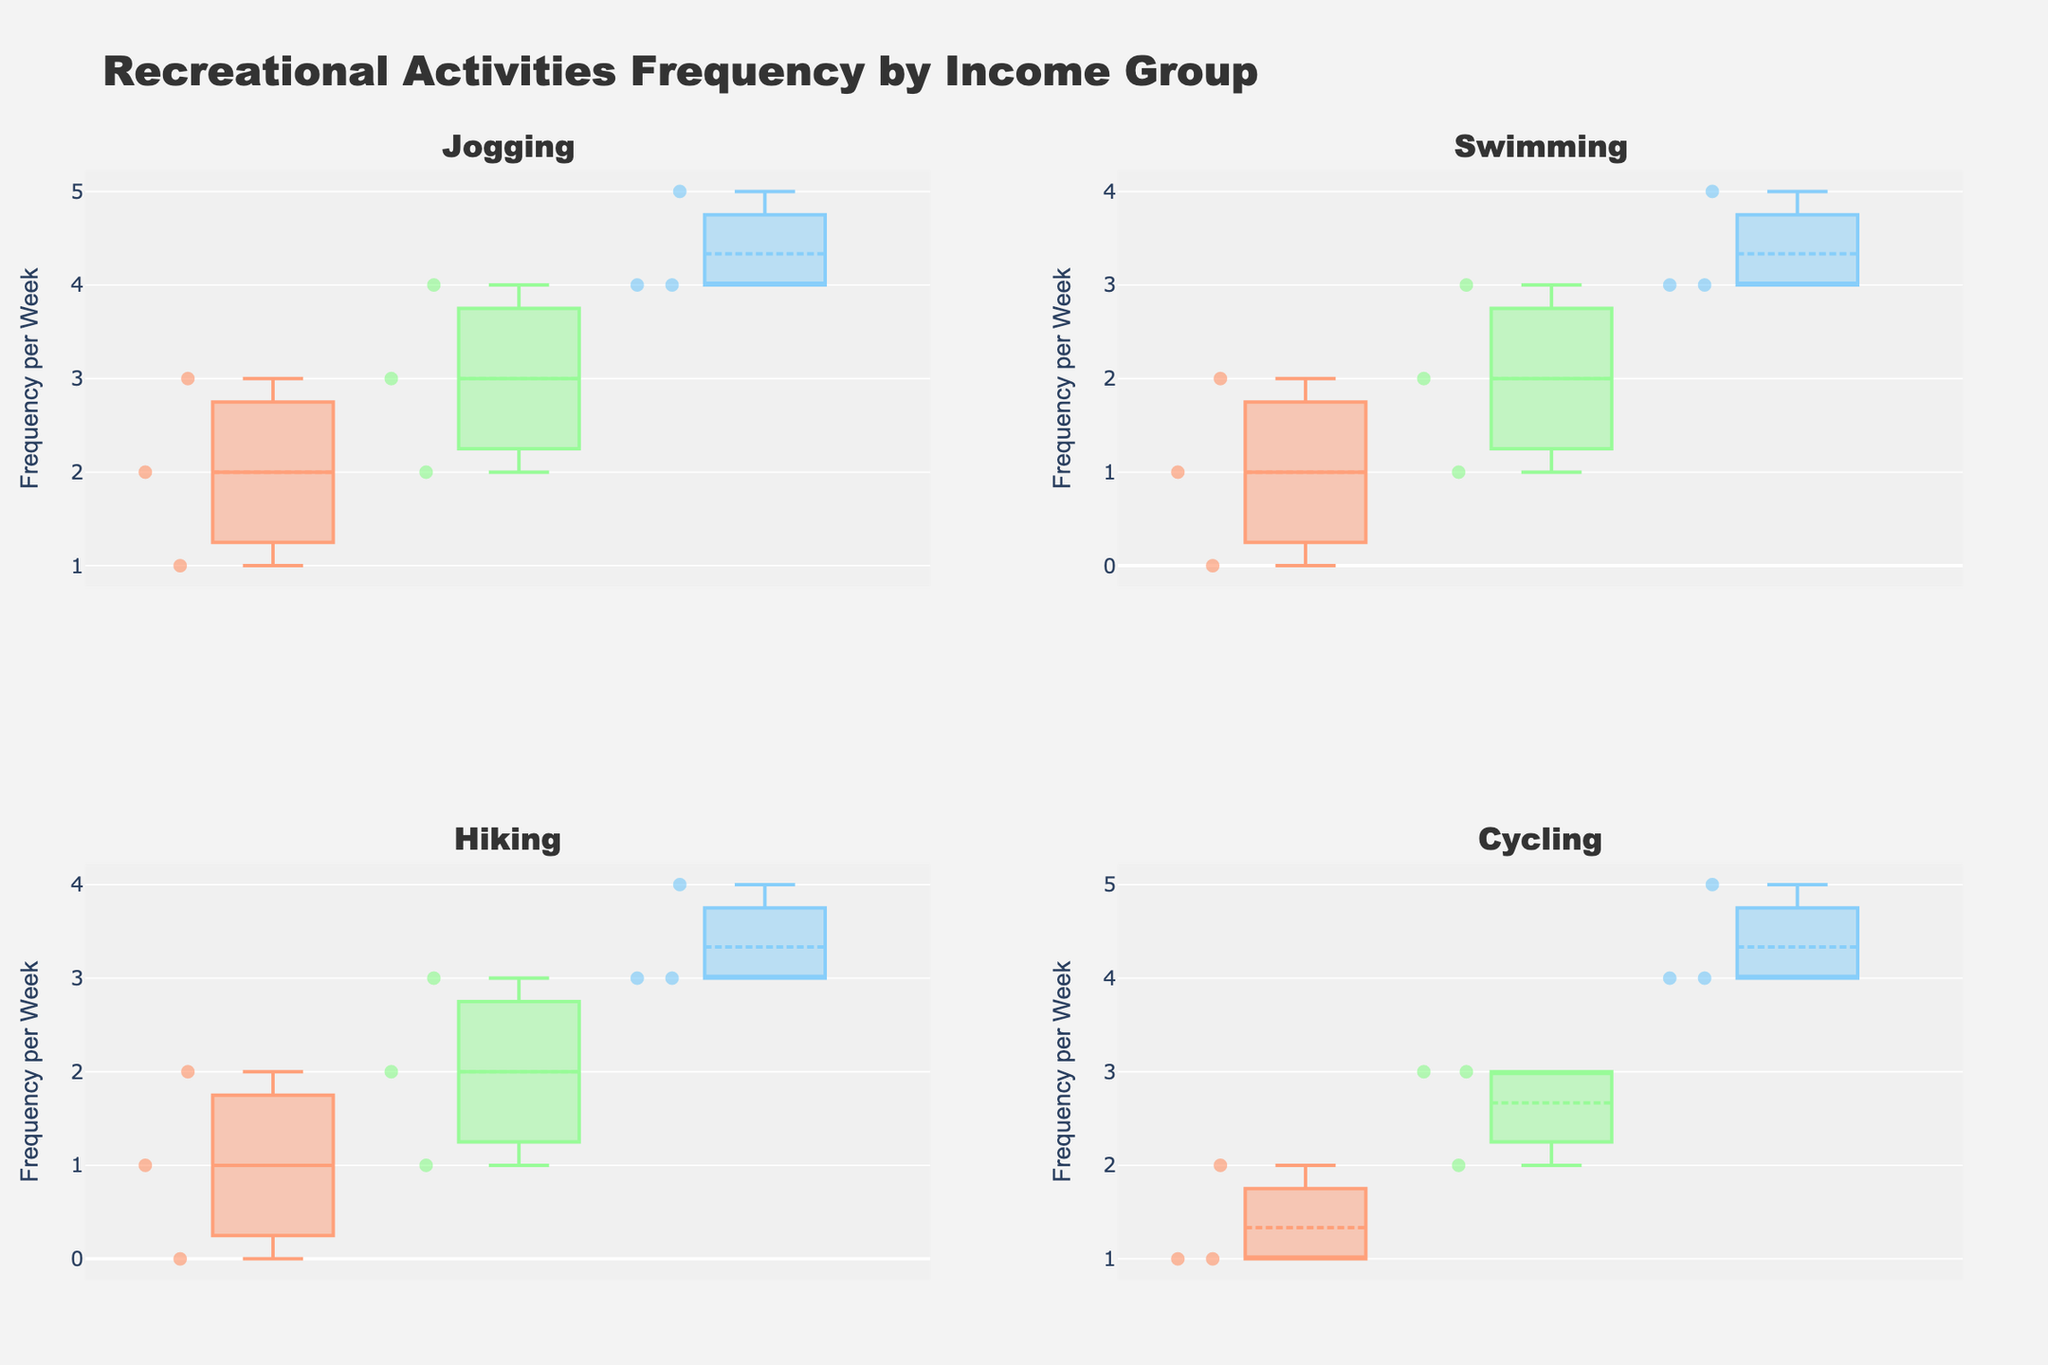What title does the figure have? The title of the figure is prominently displayed at the top.
Answer: Recreational Activities Frequency by Income Group What is the y-axis title labeled as in all subplots? The y-axis title is consistent across all subplots and located on the left side of each plot.
Answer: Frequency per Week Which income group has the highest median frequency for jogging? Look at the median line within the boxes for the jogging subplot. The high-income group has the highest median.
Answer: High For the activity "Cycling", compare the spread (interquartile range, IQR) of the frequencies between the low and high-income groups. The IQR can be assessed by looking at the height of the boxes. The box for the high-income group is taller, indicating a larger IQR compared to the low-income group.
Answer: High-income group has a larger IQR In the swimming subplot, which income group has the lowest minimum frequency value? The whiskers of the box plot indicate the minimum values. The low-income group has the lowest minimum frequency for swimming.
Answer: Low Which activity shows the largest range in frequency values within the middle-income group? The range is the distance between the smallest and largest values within a group. For the middle-income group, cycling shows the largest range.
Answer: Cycling Is the median frequency for hiking in the high-income group higher than for the low-income group? Compare the median lines within the boxes for hiking. The high-income group's median is higher than that of the low-income group.
Answer: Yes For jogging, how does the median frequency compare between the middle and high-income groups? Compare the median lines within the middle and high-income group boxes. The high-income group has a higher median frequency than the middle-income group.
Answer: High-income group is higher In which activity does the low-income group show the least variation in frequency? The height of the box indicates variation. The smallest box for the low-income group is for cycling.
Answer: Cycling What is the general trend in median frequencies for swimming across the income groups? Observing the median lines, there is an increasing trend from low to high-income groups.
Answer: Increasing trend from low to high 